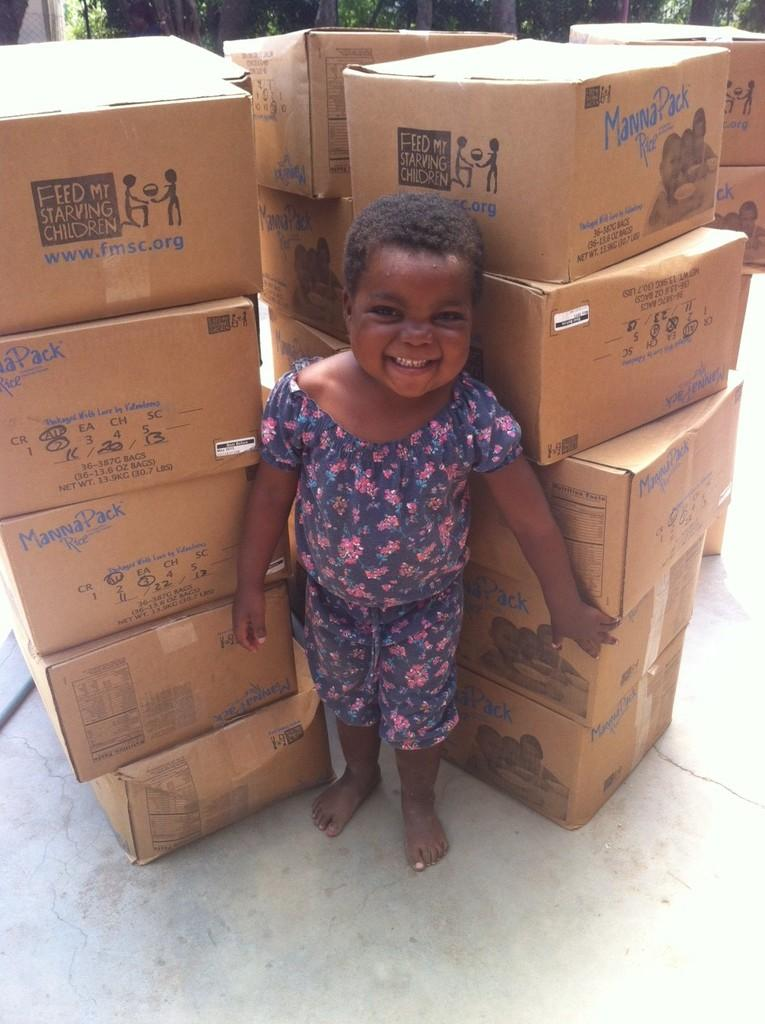Who is present in the image? There is a boy in the image. What is the boy doing in the image? The boy is standing in the image. What else can be seen in the image besides the boy? There are boxes in the image. What type of watch is the boy wearing in the image? There is no watch visible on the boy in the image. What is the boy using to stir the soup in the image? There is no soup or spoon present in the image. 